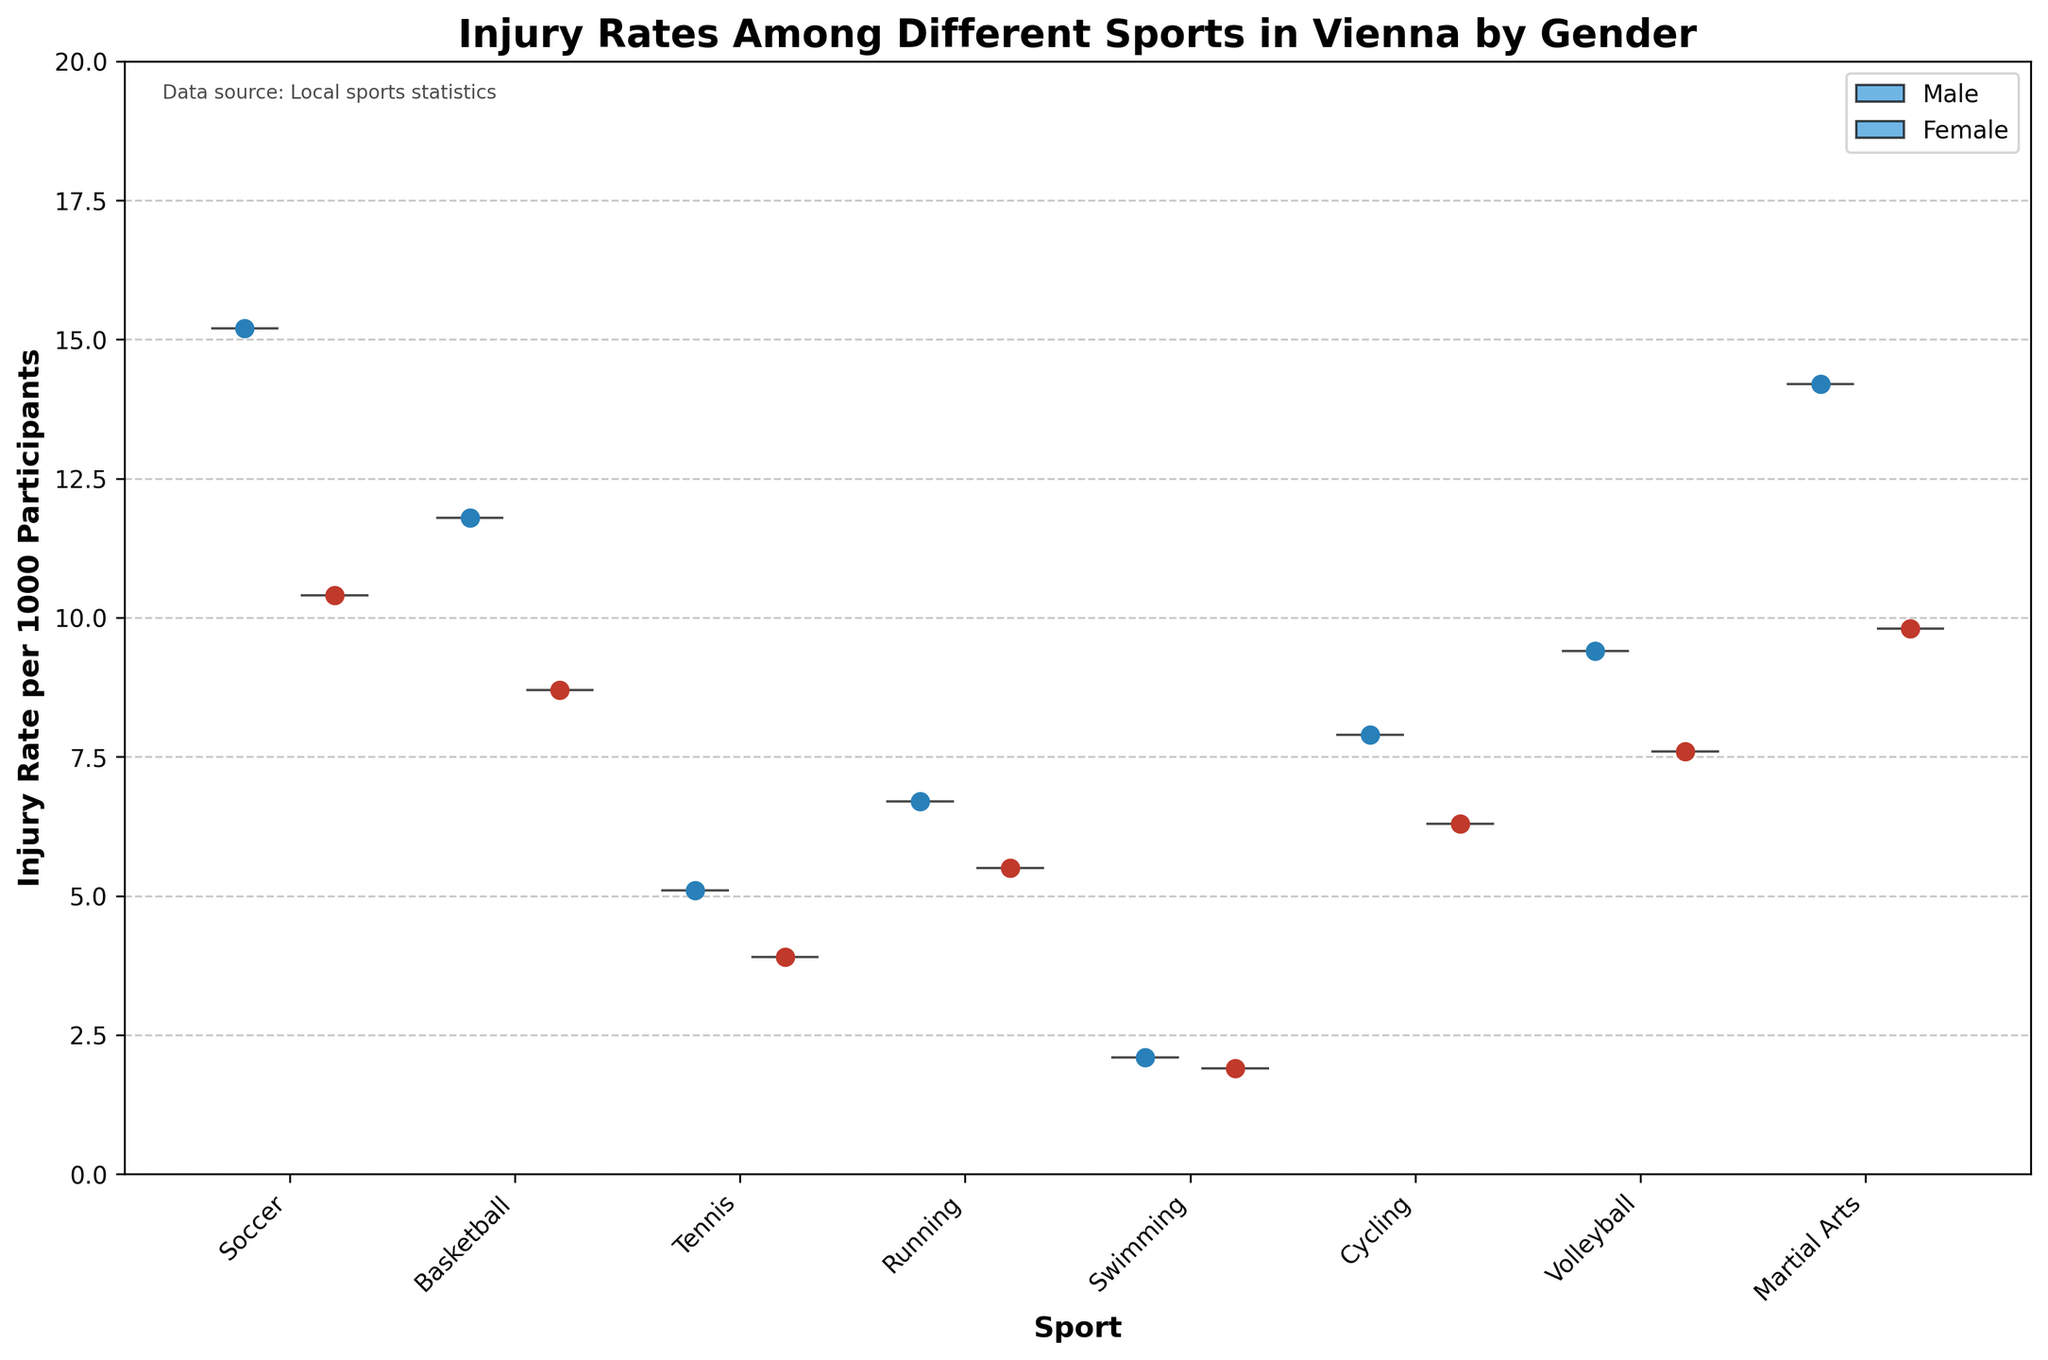How many different sports are analyzed in the chart? The chart includes data points for Soccer, Basketball, Tennis, Running, Swimming, Cycling, Volleyball, and Martial Arts. Thus, there are 8 different sports analyzed in the chart.
Answer: 8 Which sport has the highest injury rate among males? According to the chart, in the male segment, Soccer has the highest injury rate per 1000 participants, at 15.2.
Answer: Soccer What is the difference in the injury rate between male and female soccer players? The injury rate for male soccer players is 15.2 per 1000 participants, and for female soccer players, it is 10.4. The difference is 15.2 - 10.4 = 4.8.
Answer: 4.8 Which gender generally has lower injury rates across all sports? By observing the median injury rates for each sport, it can be seen that females generally have lower injury rates compared to males in multiple categories like Soccer, Basketball, and Martial Arts.
Answer: Female What is the injury rate for male participants in Tennis? The chart shows that the injury rate for male tennis players is 5.1 per 1000 participants.
Answer: 5.1 Between Running and Cycling, which sport has a higher injury rate for females, and by how much? The injury rate for female running participants is 5.5 and for cycling participants is 6.3. The difference is 6.3 - 5.5 = 0.8, so Cycling has a higher injury rate for females.
Answer: Cycling, 0.8 How do the injury rates compare between male and female Martial Arts participants? For Martial Arts, the injury rate is 14.2 per 1000 participants for males and 9.8 for females. Therefore, males have a higher injury rate by 14.2 - 9.8 = 4.4.
Answer: Males, 4.4 What's the average injury rate for both genders for the sport with the lowest injury rate? The lowest injury rate is in Swimming. The injury rates are 2.1 for males and 1.9 for females. The average is (2.1 + 1.9) / 2 = 2.0.
Answer: 2.0 Which sport has the smallest gap in injury rates between males and females? Tennis has a male injury rate of 5.1 and a female injury rate of 3.9. The difference is 5.1 - 3.9 = 1.2, which is the smallest gap among all sports.
Answer: Tennis Which sport has a higher injury rate for females compared to basketball male players, and by how much? The female sport with injury rates higher than male basketball players (11.8) does not exist. The highest female injury rate in Soccer is 10.4, which is still lower than the male basketball rate. Therefore, none out of the analyzed sports have higher female rates.
Answer: None 